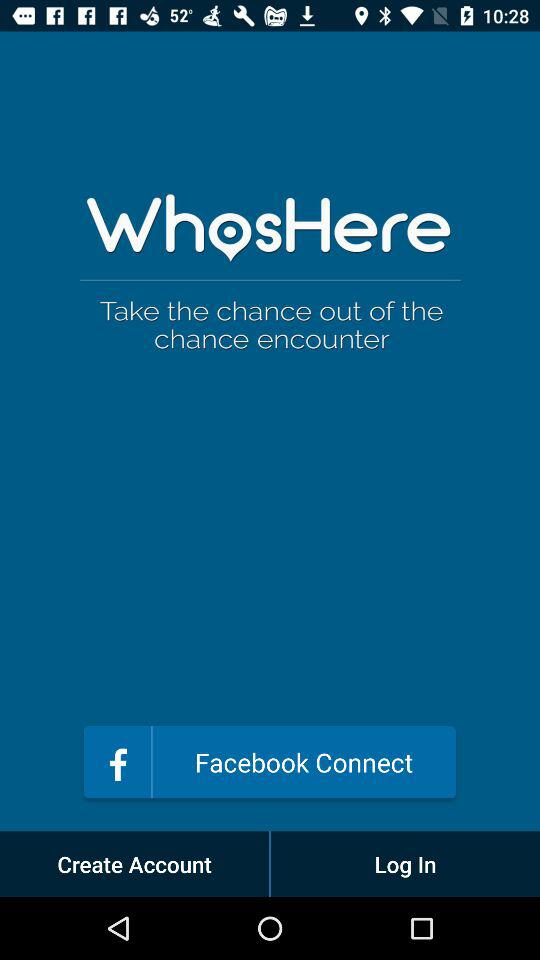What is the name of the application? The name of the application is "WhosHere". 